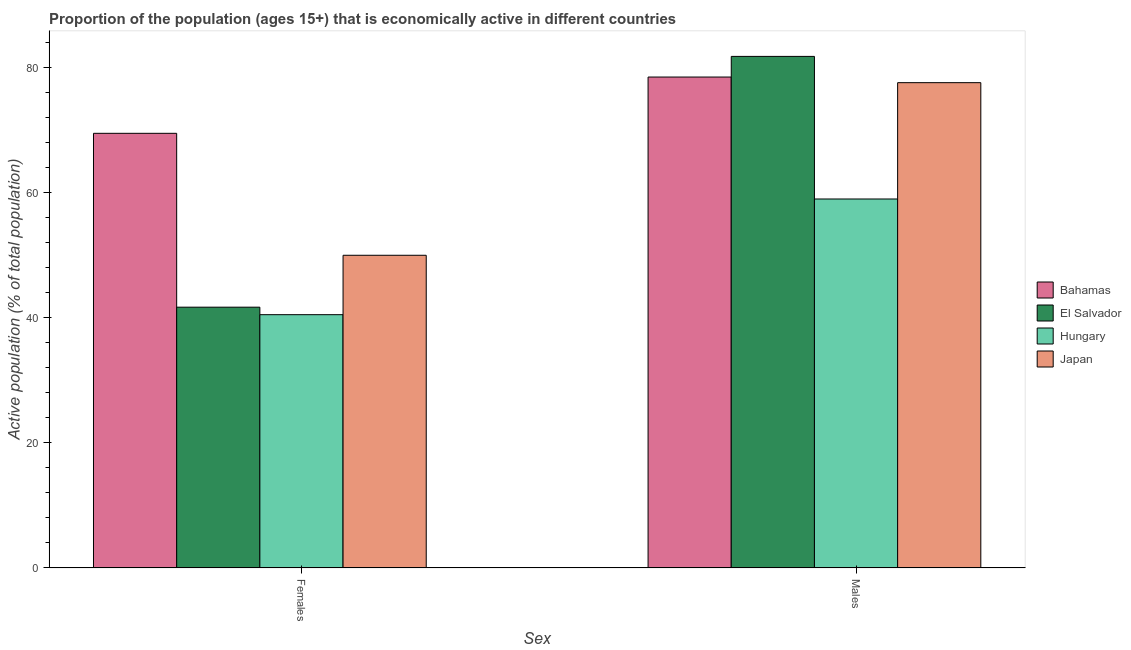How many different coloured bars are there?
Ensure brevity in your answer.  4. How many groups of bars are there?
Ensure brevity in your answer.  2. Are the number of bars on each tick of the X-axis equal?
Provide a succinct answer. Yes. How many bars are there on the 1st tick from the right?
Offer a very short reply. 4. What is the label of the 1st group of bars from the left?
Provide a short and direct response. Females. What is the percentage of economically active female population in Hungary?
Provide a succinct answer. 40.5. Across all countries, what is the maximum percentage of economically active male population?
Make the answer very short. 81.8. Across all countries, what is the minimum percentage of economically active male population?
Make the answer very short. 59. In which country was the percentage of economically active male population maximum?
Keep it short and to the point. El Salvador. In which country was the percentage of economically active male population minimum?
Keep it short and to the point. Hungary. What is the total percentage of economically active male population in the graph?
Keep it short and to the point. 296.9. What is the difference between the percentage of economically active female population in Japan and that in Hungary?
Your response must be concise. 9.5. What is the difference between the percentage of economically active female population in Japan and the percentage of economically active male population in Bahamas?
Your response must be concise. -28.5. What is the average percentage of economically active male population per country?
Provide a succinct answer. 74.23. What is the difference between the percentage of economically active female population and percentage of economically active male population in El Salvador?
Provide a short and direct response. -40.1. What is the ratio of the percentage of economically active male population in Hungary to that in El Salvador?
Keep it short and to the point. 0.72. Is the percentage of economically active male population in Bahamas less than that in El Salvador?
Provide a short and direct response. Yes. What does the 2nd bar from the right in Males represents?
Give a very brief answer. Hungary. What is the difference between two consecutive major ticks on the Y-axis?
Ensure brevity in your answer.  20. Does the graph contain any zero values?
Your answer should be very brief. No. How many legend labels are there?
Provide a short and direct response. 4. What is the title of the graph?
Your answer should be very brief. Proportion of the population (ages 15+) that is economically active in different countries. Does "Fiji" appear as one of the legend labels in the graph?
Offer a terse response. No. What is the label or title of the X-axis?
Keep it short and to the point. Sex. What is the label or title of the Y-axis?
Offer a very short reply. Active population (% of total population). What is the Active population (% of total population) of Bahamas in Females?
Provide a short and direct response. 69.5. What is the Active population (% of total population) of El Salvador in Females?
Your response must be concise. 41.7. What is the Active population (% of total population) of Hungary in Females?
Your response must be concise. 40.5. What is the Active population (% of total population) in Bahamas in Males?
Your response must be concise. 78.5. What is the Active population (% of total population) in El Salvador in Males?
Provide a succinct answer. 81.8. What is the Active population (% of total population) in Japan in Males?
Make the answer very short. 77.6. Across all Sex, what is the maximum Active population (% of total population) in Bahamas?
Your answer should be very brief. 78.5. Across all Sex, what is the maximum Active population (% of total population) in El Salvador?
Your answer should be compact. 81.8. Across all Sex, what is the maximum Active population (% of total population) of Japan?
Provide a short and direct response. 77.6. Across all Sex, what is the minimum Active population (% of total population) of Bahamas?
Keep it short and to the point. 69.5. Across all Sex, what is the minimum Active population (% of total population) in El Salvador?
Ensure brevity in your answer.  41.7. Across all Sex, what is the minimum Active population (% of total population) in Hungary?
Offer a terse response. 40.5. What is the total Active population (% of total population) of Bahamas in the graph?
Offer a very short reply. 148. What is the total Active population (% of total population) of El Salvador in the graph?
Offer a very short reply. 123.5. What is the total Active population (% of total population) of Hungary in the graph?
Offer a terse response. 99.5. What is the total Active population (% of total population) in Japan in the graph?
Make the answer very short. 127.6. What is the difference between the Active population (% of total population) of Bahamas in Females and that in Males?
Your answer should be very brief. -9. What is the difference between the Active population (% of total population) in El Salvador in Females and that in Males?
Your answer should be compact. -40.1. What is the difference between the Active population (% of total population) in Hungary in Females and that in Males?
Offer a terse response. -18.5. What is the difference between the Active population (% of total population) in Japan in Females and that in Males?
Keep it short and to the point. -27.6. What is the difference between the Active population (% of total population) in Bahamas in Females and the Active population (% of total population) in El Salvador in Males?
Ensure brevity in your answer.  -12.3. What is the difference between the Active population (% of total population) in Bahamas in Females and the Active population (% of total population) in Hungary in Males?
Make the answer very short. 10.5. What is the difference between the Active population (% of total population) in Bahamas in Females and the Active population (% of total population) in Japan in Males?
Provide a succinct answer. -8.1. What is the difference between the Active population (% of total population) in El Salvador in Females and the Active population (% of total population) in Hungary in Males?
Ensure brevity in your answer.  -17.3. What is the difference between the Active population (% of total population) in El Salvador in Females and the Active population (% of total population) in Japan in Males?
Your response must be concise. -35.9. What is the difference between the Active population (% of total population) in Hungary in Females and the Active population (% of total population) in Japan in Males?
Provide a short and direct response. -37.1. What is the average Active population (% of total population) of El Salvador per Sex?
Offer a very short reply. 61.75. What is the average Active population (% of total population) in Hungary per Sex?
Ensure brevity in your answer.  49.75. What is the average Active population (% of total population) in Japan per Sex?
Keep it short and to the point. 63.8. What is the difference between the Active population (% of total population) of Bahamas and Active population (% of total population) of El Salvador in Females?
Offer a very short reply. 27.8. What is the difference between the Active population (% of total population) of Bahamas and Active population (% of total population) of Hungary in Females?
Your answer should be very brief. 29. What is the difference between the Active population (% of total population) of El Salvador and Active population (% of total population) of Japan in Females?
Keep it short and to the point. -8.3. What is the difference between the Active population (% of total population) of Hungary and Active population (% of total population) of Japan in Females?
Your answer should be very brief. -9.5. What is the difference between the Active population (% of total population) of Bahamas and Active population (% of total population) of Hungary in Males?
Offer a terse response. 19.5. What is the difference between the Active population (% of total population) of El Salvador and Active population (% of total population) of Hungary in Males?
Your response must be concise. 22.8. What is the difference between the Active population (% of total population) in El Salvador and Active population (% of total population) in Japan in Males?
Provide a succinct answer. 4.2. What is the difference between the Active population (% of total population) of Hungary and Active population (% of total population) of Japan in Males?
Provide a short and direct response. -18.6. What is the ratio of the Active population (% of total population) of Bahamas in Females to that in Males?
Make the answer very short. 0.89. What is the ratio of the Active population (% of total population) in El Salvador in Females to that in Males?
Provide a short and direct response. 0.51. What is the ratio of the Active population (% of total population) in Hungary in Females to that in Males?
Your answer should be very brief. 0.69. What is the ratio of the Active population (% of total population) in Japan in Females to that in Males?
Offer a terse response. 0.64. What is the difference between the highest and the second highest Active population (% of total population) of El Salvador?
Your answer should be compact. 40.1. What is the difference between the highest and the second highest Active population (% of total population) in Japan?
Provide a succinct answer. 27.6. What is the difference between the highest and the lowest Active population (% of total population) of El Salvador?
Ensure brevity in your answer.  40.1. What is the difference between the highest and the lowest Active population (% of total population) of Japan?
Provide a succinct answer. 27.6. 